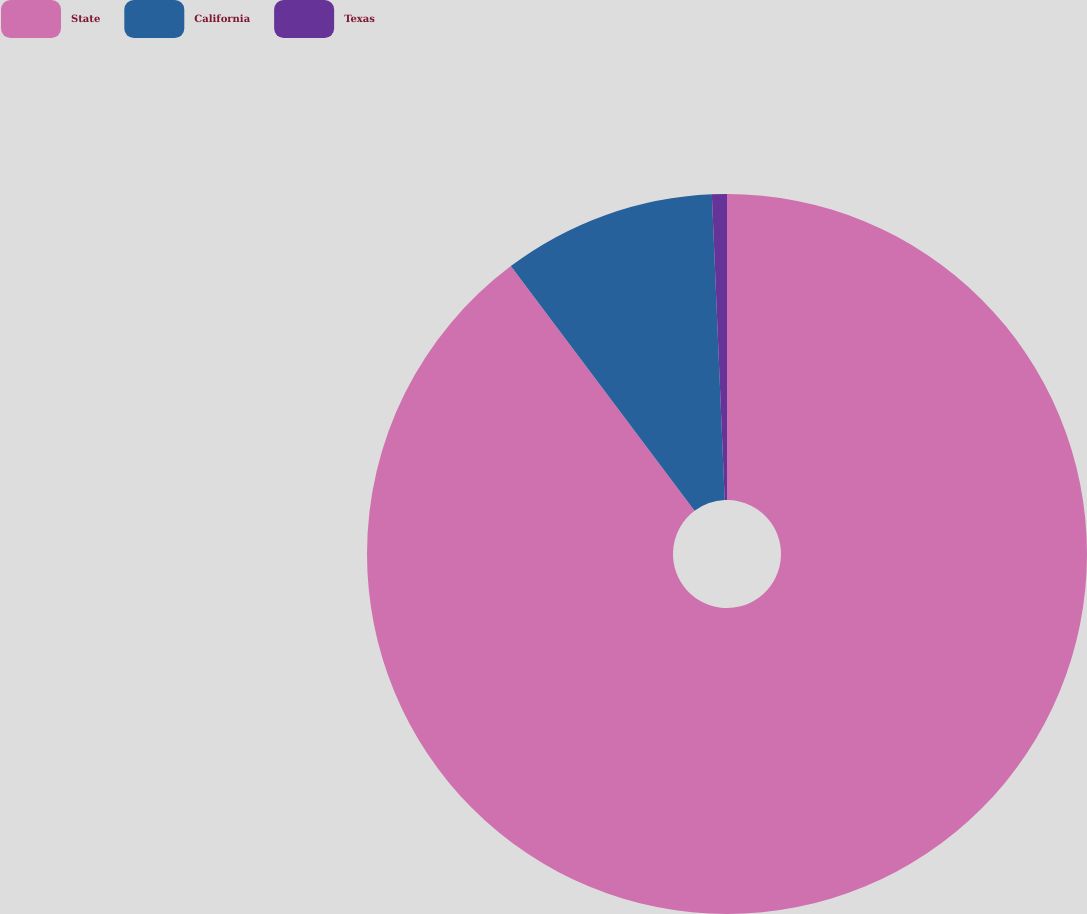<chart> <loc_0><loc_0><loc_500><loc_500><pie_chart><fcel>State<fcel>California<fcel>Texas<nl><fcel>89.75%<fcel>9.58%<fcel>0.67%<nl></chart> 